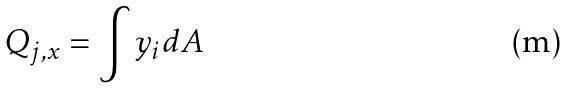<formula> <loc_0><loc_0><loc_500><loc_500>Q _ { j , x } = \int y _ { i } d A</formula> 